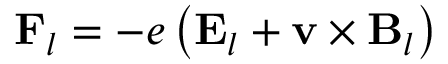Convert formula to latex. <formula><loc_0><loc_0><loc_500><loc_500>F _ { l } = - e \left ( E _ { l } + v \times B _ { l } \right )</formula> 